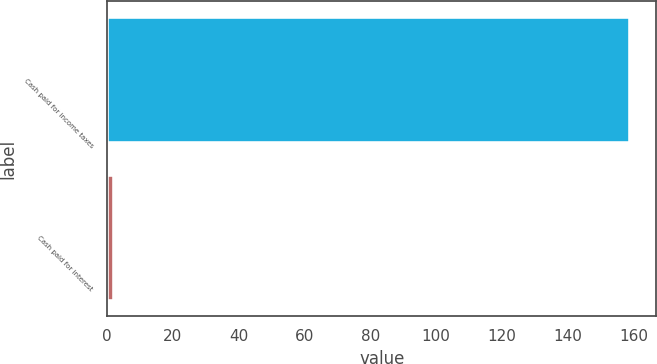Convert chart to OTSL. <chart><loc_0><loc_0><loc_500><loc_500><bar_chart><fcel>Cash paid for income taxes<fcel>Cash paid for interest<nl><fcel>159<fcel>2<nl></chart> 